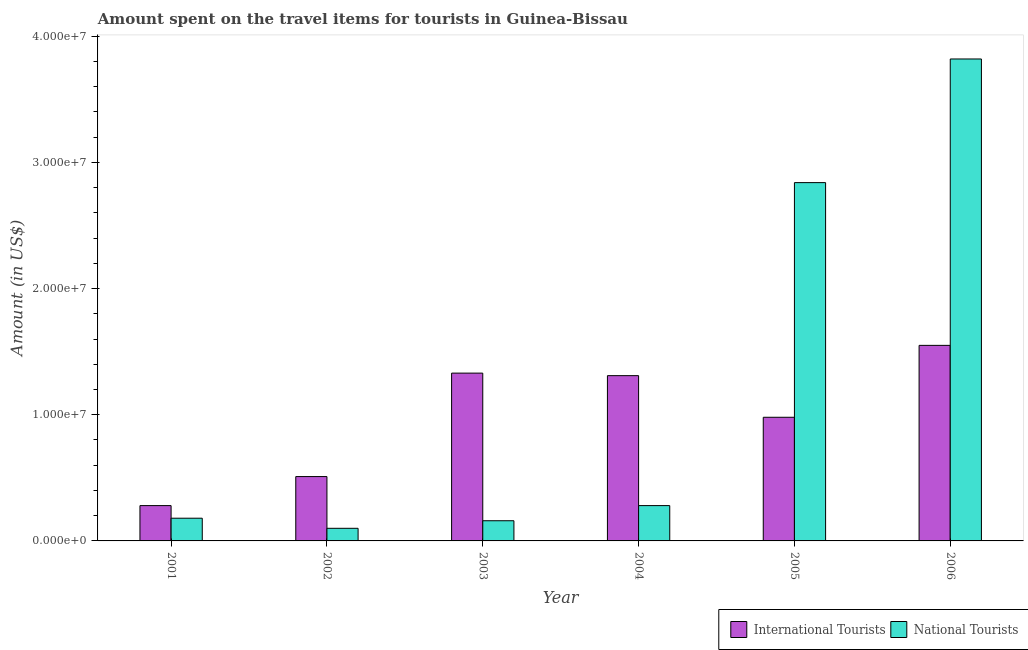How many different coloured bars are there?
Offer a very short reply. 2. Are the number of bars on each tick of the X-axis equal?
Offer a terse response. Yes. How many bars are there on the 6th tick from the left?
Your response must be concise. 2. In how many cases, is the number of bars for a given year not equal to the number of legend labels?
Make the answer very short. 0. What is the amount spent on travel items of national tourists in 2002?
Keep it short and to the point. 1.00e+06. Across all years, what is the maximum amount spent on travel items of national tourists?
Your answer should be very brief. 3.82e+07. Across all years, what is the minimum amount spent on travel items of international tourists?
Offer a very short reply. 2.80e+06. In which year was the amount spent on travel items of international tourists minimum?
Offer a very short reply. 2001. What is the total amount spent on travel items of national tourists in the graph?
Keep it short and to the point. 7.38e+07. What is the difference between the amount spent on travel items of national tourists in 2003 and that in 2006?
Offer a very short reply. -3.66e+07. What is the difference between the amount spent on travel items of international tourists in 2005 and the amount spent on travel items of national tourists in 2004?
Ensure brevity in your answer.  -3.30e+06. What is the average amount spent on travel items of international tourists per year?
Ensure brevity in your answer.  9.93e+06. In how many years, is the amount spent on travel items of national tourists greater than 38000000 US$?
Ensure brevity in your answer.  1. What is the ratio of the amount spent on travel items of international tourists in 2005 to that in 2006?
Your answer should be very brief. 0.63. What is the difference between the highest and the second highest amount spent on travel items of international tourists?
Your answer should be compact. 2.20e+06. What is the difference between the highest and the lowest amount spent on travel items of national tourists?
Your answer should be very brief. 3.72e+07. What does the 1st bar from the left in 2001 represents?
Make the answer very short. International Tourists. What does the 2nd bar from the right in 2001 represents?
Provide a short and direct response. International Tourists. How many bars are there?
Make the answer very short. 12. What is the difference between two consecutive major ticks on the Y-axis?
Your answer should be compact. 1.00e+07. Does the graph contain any zero values?
Your response must be concise. No. Does the graph contain grids?
Provide a succinct answer. No. Where does the legend appear in the graph?
Make the answer very short. Bottom right. How are the legend labels stacked?
Give a very brief answer. Horizontal. What is the title of the graph?
Ensure brevity in your answer.  Amount spent on the travel items for tourists in Guinea-Bissau. Does "Domestic Liabilities" appear as one of the legend labels in the graph?
Offer a very short reply. No. What is the label or title of the X-axis?
Your response must be concise. Year. What is the label or title of the Y-axis?
Your answer should be compact. Amount (in US$). What is the Amount (in US$) of International Tourists in 2001?
Offer a terse response. 2.80e+06. What is the Amount (in US$) in National Tourists in 2001?
Ensure brevity in your answer.  1.80e+06. What is the Amount (in US$) of International Tourists in 2002?
Your answer should be compact. 5.10e+06. What is the Amount (in US$) of International Tourists in 2003?
Your answer should be compact. 1.33e+07. What is the Amount (in US$) in National Tourists in 2003?
Give a very brief answer. 1.60e+06. What is the Amount (in US$) in International Tourists in 2004?
Your answer should be compact. 1.31e+07. What is the Amount (in US$) in National Tourists in 2004?
Make the answer very short. 2.80e+06. What is the Amount (in US$) in International Tourists in 2005?
Your answer should be compact. 9.80e+06. What is the Amount (in US$) in National Tourists in 2005?
Offer a very short reply. 2.84e+07. What is the Amount (in US$) in International Tourists in 2006?
Keep it short and to the point. 1.55e+07. What is the Amount (in US$) in National Tourists in 2006?
Your answer should be compact. 3.82e+07. Across all years, what is the maximum Amount (in US$) of International Tourists?
Make the answer very short. 1.55e+07. Across all years, what is the maximum Amount (in US$) of National Tourists?
Provide a short and direct response. 3.82e+07. Across all years, what is the minimum Amount (in US$) in International Tourists?
Your answer should be very brief. 2.80e+06. Across all years, what is the minimum Amount (in US$) of National Tourists?
Give a very brief answer. 1.00e+06. What is the total Amount (in US$) in International Tourists in the graph?
Offer a terse response. 5.96e+07. What is the total Amount (in US$) in National Tourists in the graph?
Make the answer very short. 7.38e+07. What is the difference between the Amount (in US$) in International Tourists in 2001 and that in 2002?
Keep it short and to the point. -2.30e+06. What is the difference between the Amount (in US$) of International Tourists in 2001 and that in 2003?
Provide a short and direct response. -1.05e+07. What is the difference between the Amount (in US$) in National Tourists in 2001 and that in 2003?
Provide a short and direct response. 2.00e+05. What is the difference between the Amount (in US$) of International Tourists in 2001 and that in 2004?
Ensure brevity in your answer.  -1.03e+07. What is the difference between the Amount (in US$) of National Tourists in 2001 and that in 2004?
Ensure brevity in your answer.  -1.00e+06. What is the difference between the Amount (in US$) of International Tourists in 2001 and that in 2005?
Offer a very short reply. -7.00e+06. What is the difference between the Amount (in US$) in National Tourists in 2001 and that in 2005?
Provide a short and direct response. -2.66e+07. What is the difference between the Amount (in US$) of International Tourists in 2001 and that in 2006?
Keep it short and to the point. -1.27e+07. What is the difference between the Amount (in US$) in National Tourists in 2001 and that in 2006?
Offer a very short reply. -3.64e+07. What is the difference between the Amount (in US$) in International Tourists in 2002 and that in 2003?
Your answer should be very brief. -8.20e+06. What is the difference between the Amount (in US$) of National Tourists in 2002 and that in 2003?
Your answer should be compact. -6.00e+05. What is the difference between the Amount (in US$) in International Tourists in 2002 and that in 2004?
Offer a terse response. -8.00e+06. What is the difference between the Amount (in US$) of National Tourists in 2002 and that in 2004?
Your answer should be compact. -1.80e+06. What is the difference between the Amount (in US$) in International Tourists in 2002 and that in 2005?
Your answer should be compact. -4.70e+06. What is the difference between the Amount (in US$) of National Tourists in 2002 and that in 2005?
Provide a short and direct response. -2.74e+07. What is the difference between the Amount (in US$) of International Tourists in 2002 and that in 2006?
Make the answer very short. -1.04e+07. What is the difference between the Amount (in US$) in National Tourists in 2002 and that in 2006?
Your answer should be compact. -3.72e+07. What is the difference between the Amount (in US$) in National Tourists in 2003 and that in 2004?
Give a very brief answer. -1.20e+06. What is the difference between the Amount (in US$) of International Tourists in 2003 and that in 2005?
Your answer should be very brief. 3.50e+06. What is the difference between the Amount (in US$) in National Tourists in 2003 and that in 2005?
Provide a succinct answer. -2.68e+07. What is the difference between the Amount (in US$) of International Tourists in 2003 and that in 2006?
Offer a terse response. -2.20e+06. What is the difference between the Amount (in US$) in National Tourists in 2003 and that in 2006?
Your response must be concise. -3.66e+07. What is the difference between the Amount (in US$) of International Tourists in 2004 and that in 2005?
Ensure brevity in your answer.  3.30e+06. What is the difference between the Amount (in US$) of National Tourists in 2004 and that in 2005?
Give a very brief answer. -2.56e+07. What is the difference between the Amount (in US$) of International Tourists in 2004 and that in 2006?
Ensure brevity in your answer.  -2.40e+06. What is the difference between the Amount (in US$) in National Tourists in 2004 and that in 2006?
Offer a very short reply. -3.54e+07. What is the difference between the Amount (in US$) of International Tourists in 2005 and that in 2006?
Give a very brief answer. -5.70e+06. What is the difference between the Amount (in US$) in National Tourists in 2005 and that in 2006?
Your answer should be very brief. -9.80e+06. What is the difference between the Amount (in US$) in International Tourists in 2001 and the Amount (in US$) in National Tourists in 2002?
Your answer should be compact. 1.80e+06. What is the difference between the Amount (in US$) in International Tourists in 2001 and the Amount (in US$) in National Tourists in 2003?
Provide a short and direct response. 1.20e+06. What is the difference between the Amount (in US$) of International Tourists in 2001 and the Amount (in US$) of National Tourists in 2005?
Your response must be concise. -2.56e+07. What is the difference between the Amount (in US$) in International Tourists in 2001 and the Amount (in US$) in National Tourists in 2006?
Provide a succinct answer. -3.54e+07. What is the difference between the Amount (in US$) in International Tourists in 2002 and the Amount (in US$) in National Tourists in 2003?
Keep it short and to the point. 3.50e+06. What is the difference between the Amount (in US$) of International Tourists in 2002 and the Amount (in US$) of National Tourists in 2004?
Ensure brevity in your answer.  2.30e+06. What is the difference between the Amount (in US$) in International Tourists in 2002 and the Amount (in US$) in National Tourists in 2005?
Keep it short and to the point. -2.33e+07. What is the difference between the Amount (in US$) of International Tourists in 2002 and the Amount (in US$) of National Tourists in 2006?
Offer a terse response. -3.31e+07. What is the difference between the Amount (in US$) of International Tourists in 2003 and the Amount (in US$) of National Tourists in 2004?
Keep it short and to the point. 1.05e+07. What is the difference between the Amount (in US$) in International Tourists in 2003 and the Amount (in US$) in National Tourists in 2005?
Your answer should be compact. -1.51e+07. What is the difference between the Amount (in US$) of International Tourists in 2003 and the Amount (in US$) of National Tourists in 2006?
Your response must be concise. -2.49e+07. What is the difference between the Amount (in US$) in International Tourists in 2004 and the Amount (in US$) in National Tourists in 2005?
Keep it short and to the point. -1.53e+07. What is the difference between the Amount (in US$) of International Tourists in 2004 and the Amount (in US$) of National Tourists in 2006?
Make the answer very short. -2.51e+07. What is the difference between the Amount (in US$) of International Tourists in 2005 and the Amount (in US$) of National Tourists in 2006?
Ensure brevity in your answer.  -2.84e+07. What is the average Amount (in US$) in International Tourists per year?
Keep it short and to the point. 9.93e+06. What is the average Amount (in US$) in National Tourists per year?
Ensure brevity in your answer.  1.23e+07. In the year 2002, what is the difference between the Amount (in US$) in International Tourists and Amount (in US$) in National Tourists?
Provide a short and direct response. 4.10e+06. In the year 2003, what is the difference between the Amount (in US$) of International Tourists and Amount (in US$) of National Tourists?
Keep it short and to the point. 1.17e+07. In the year 2004, what is the difference between the Amount (in US$) of International Tourists and Amount (in US$) of National Tourists?
Make the answer very short. 1.03e+07. In the year 2005, what is the difference between the Amount (in US$) of International Tourists and Amount (in US$) of National Tourists?
Offer a terse response. -1.86e+07. In the year 2006, what is the difference between the Amount (in US$) in International Tourists and Amount (in US$) in National Tourists?
Make the answer very short. -2.27e+07. What is the ratio of the Amount (in US$) of International Tourists in 2001 to that in 2002?
Your answer should be very brief. 0.55. What is the ratio of the Amount (in US$) of International Tourists in 2001 to that in 2003?
Give a very brief answer. 0.21. What is the ratio of the Amount (in US$) of National Tourists in 2001 to that in 2003?
Your answer should be compact. 1.12. What is the ratio of the Amount (in US$) in International Tourists in 2001 to that in 2004?
Ensure brevity in your answer.  0.21. What is the ratio of the Amount (in US$) of National Tourists in 2001 to that in 2004?
Your answer should be compact. 0.64. What is the ratio of the Amount (in US$) in International Tourists in 2001 to that in 2005?
Ensure brevity in your answer.  0.29. What is the ratio of the Amount (in US$) of National Tourists in 2001 to that in 2005?
Your answer should be compact. 0.06. What is the ratio of the Amount (in US$) in International Tourists in 2001 to that in 2006?
Ensure brevity in your answer.  0.18. What is the ratio of the Amount (in US$) of National Tourists in 2001 to that in 2006?
Your answer should be compact. 0.05. What is the ratio of the Amount (in US$) in International Tourists in 2002 to that in 2003?
Offer a terse response. 0.38. What is the ratio of the Amount (in US$) of International Tourists in 2002 to that in 2004?
Your answer should be compact. 0.39. What is the ratio of the Amount (in US$) in National Tourists in 2002 to that in 2004?
Offer a terse response. 0.36. What is the ratio of the Amount (in US$) of International Tourists in 2002 to that in 2005?
Offer a very short reply. 0.52. What is the ratio of the Amount (in US$) of National Tourists in 2002 to that in 2005?
Your answer should be compact. 0.04. What is the ratio of the Amount (in US$) of International Tourists in 2002 to that in 2006?
Your answer should be very brief. 0.33. What is the ratio of the Amount (in US$) in National Tourists in 2002 to that in 2006?
Give a very brief answer. 0.03. What is the ratio of the Amount (in US$) of International Tourists in 2003 to that in 2004?
Keep it short and to the point. 1.02. What is the ratio of the Amount (in US$) in National Tourists in 2003 to that in 2004?
Provide a short and direct response. 0.57. What is the ratio of the Amount (in US$) in International Tourists in 2003 to that in 2005?
Provide a succinct answer. 1.36. What is the ratio of the Amount (in US$) of National Tourists in 2003 to that in 2005?
Your response must be concise. 0.06. What is the ratio of the Amount (in US$) of International Tourists in 2003 to that in 2006?
Provide a short and direct response. 0.86. What is the ratio of the Amount (in US$) of National Tourists in 2003 to that in 2006?
Offer a terse response. 0.04. What is the ratio of the Amount (in US$) of International Tourists in 2004 to that in 2005?
Make the answer very short. 1.34. What is the ratio of the Amount (in US$) in National Tourists in 2004 to that in 2005?
Your response must be concise. 0.1. What is the ratio of the Amount (in US$) of International Tourists in 2004 to that in 2006?
Your answer should be compact. 0.85. What is the ratio of the Amount (in US$) of National Tourists in 2004 to that in 2006?
Your answer should be very brief. 0.07. What is the ratio of the Amount (in US$) in International Tourists in 2005 to that in 2006?
Your response must be concise. 0.63. What is the ratio of the Amount (in US$) in National Tourists in 2005 to that in 2006?
Provide a succinct answer. 0.74. What is the difference between the highest and the second highest Amount (in US$) of International Tourists?
Give a very brief answer. 2.20e+06. What is the difference between the highest and the second highest Amount (in US$) in National Tourists?
Your answer should be compact. 9.80e+06. What is the difference between the highest and the lowest Amount (in US$) of International Tourists?
Your answer should be very brief. 1.27e+07. What is the difference between the highest and the lowest Amount (in US$) in National Tourists?
Provide a short and direct response. 3.72e+07. 